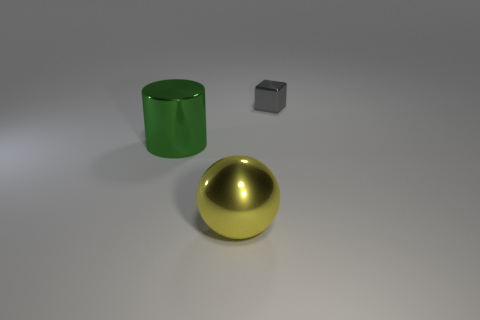Are there the same number of big yellow balls that are to the right of the yellow metallic thing and small gray metal objects?
Your response must be concise. No. There is a object that is behind the object to the left of the yellow metallic thing; how many yellow metallic spheres are right of it?
Give a very brief answer. 0. Are there any blocks that have the same size as the yellow metallic sphere?
Your answer should be compact. No. Are there fewer shiny objects on the left side of the big green shiny object than tiny green cylinders?
Your response must be concise. No. What is the material of the thing to the right of the metallic thing in front of the large metallic object behind the big yellow shiny object?
Provide a short and direct response. Metal. Are there more metal cylinders that are in front of the yellow shiny ball than big green metallic cylinders that are behind the large green metallic object?
Keep it short and to the point. No. What number of metal things are cylinders or small balls?
Keep it short and to the point. 1. What material is the large thing that is left of the yellow shiny object?
Give a very brief answer. Metal. What number of things are tiny gray objects or things on the left side of the gray cube?
Give a very brief answer. 3. The yellow shiny thing that is the same size as the metal cylinder is what shape?
Keep it short and to the point. Sphere. 